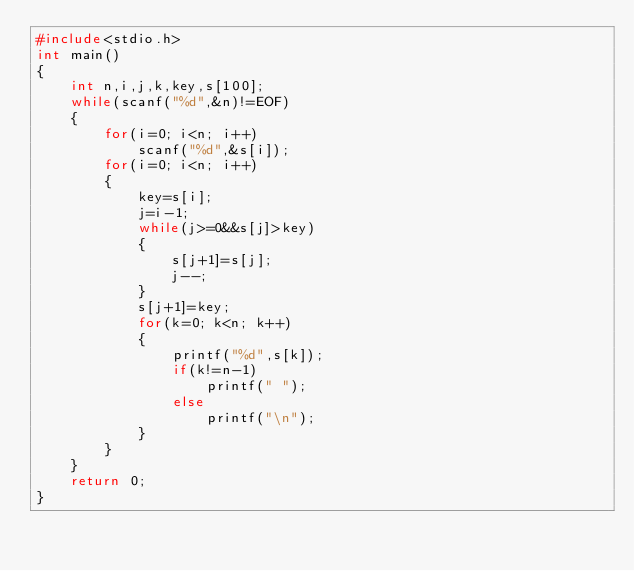Convert code to text. <code><loc_0><loc_0><loc_500><loc_500><_C_>#include<stdio.h>
int main()
{
    int n,i,j,k,key,s[100];
    while(scanf("%d",&n)!=EOF)
    {
        for(i=0; i<n; i++)
            scanf("%d",&s[i]);
        for(i=0; i<n; i++)
        {
            key=s[i];
            j=i-1;
            while(j>=0&&s[j]>key)
            {
                s[j+1]=s[j];
                j--;
            }
            s[j+1]=key;
            for(k=0; k<n; k++)
            {
                printf("%d",s[k]);
                if(k!=n-1)
                    printf(" ");
                else
                    printf("\n");
            }
        }
    }
    return 0;
}

</code> 